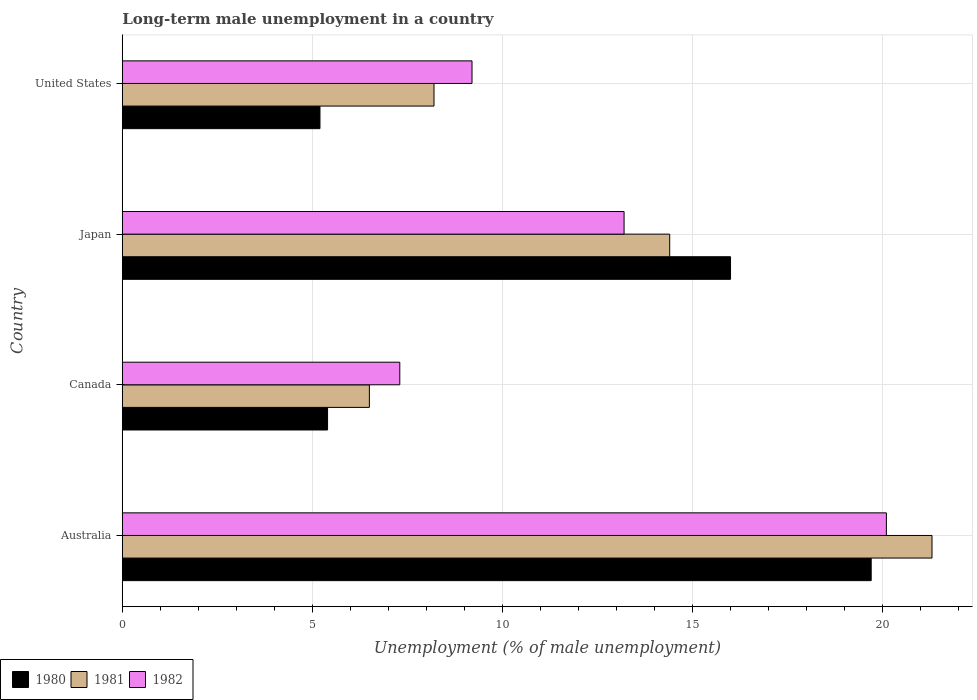Are the number of bars on each tick of the Y-axis equal?
Make the answer very short. Yes. How many bars are there on the 4th tick from the bottom?
Provide a succinct answer. 3. In how many cases, is the number of bars for a given country not equal to the number of legend labels?
Keep it short and to the point. 0. What is the percentage of long-term unemployed male population in 1981 in Japan?
Keep it short and to the point. 14.4. Across all countries, what is the maximum percentage of long-term unemployed male population in 1980?
Make the answer very short. 19.7. In which country was the percentage of long-term unemployed male population in 1981 maximum?
Provide a succinct answer. Australia. What is the total percentage of long-term unemployed male population in 1982 in the graph?
Your answer should be compact. 49.8. What is the difference between the percentage of long-term unemployed male population in 1980 in Japan and that in United States?
Provide a short and direct response. 10.8. What is the difference between the percentage of long-term unemployed male population in 1981 in Canada and the percentage of long-term unemployed male population in 1980 in United States?
Offer a very short reply. 1.3. What is the average percentage of long-term unemployed male population in 1980 per country?
Your answer should be very brief. 11.58. What is the difference between the percentage of long-term unemployed male population in 1982 and percentage of long-term unemployed male population in 1980 in Canada?
Give a very brief answer. 1.9. In how many countries, is the percentage of long-term unemployed male population in 1981 greater than 19 %?
Offer a terse response. 1. What is the ratio of the percentage of long-term unemployed male population in 1982 in Australia to that in Canada?
Provide a succinct answer. 2.75. Is the percentage of long-term unemployed male population in 1982 in Australia less than that in Japan?
Give a very brief answer. No. What is the difference between the highest and the second highest percentage of long-term unemployed male population in 1981?
Your answer should be compact. 6.9. What is the difference between the highest and the lowest percentage of long-term unemployed male population in 1981?
Offer a terse response. 14.8. Is the sum of the percentage of long-term unemployed male population in 1982 in Japan and United States greater than the maximum percentage of long-term unemployed male population in 1981 across all countries?
Offer a terse response. Yes. What does the 3rd bar from the top in Australia represents?
Your response must be concise. 1980. What does the 2nd bar from the bottom in Australia represents?
Provide a succinct answer. 1981. Is it the case that in every country, the sum of the percentage of long-term unemployed male population in 1980 and percentage of long-term unemployed male population in 1982 is greater than the percentage of long-term unemployed male population in 1981?
Offer a very short reply. Yes. Does the graph contain any zero values?
Offer a very short reply. No. Does the graph contain grids?
Offer a terse response. Yes. How many legend labels are there?
Give a very brief answer. 3. How are the legend labels stacked?
Keep it short and to the point. Horizontal. What is the title of the graph?
Keep it short and to the point. Long-term male unemployment in a country. Does "1962" appear as one of the legend labels in the graph?
Your response must be concise. No. What is the label or title of the X-axis?
Offer a terse response. Unemployment (% of male unemployment). What is the label or title of the Y-axis?
Keep it short and to the point. Country. What is the Unemployment (% of male unemployment) in 1980 in Australia?
Ensure brevity in your answer.  19.7. What is the Unemployment (% of male unemployment) of 1981 in Australia?
Your answer should be compact. 21.3. What is the Unemployment (% of male unemployment) of 1982 in Australia?
Provide a short and direct response. 20.1. What is the Unemployment (% of male unemployment) of 1980 in Canada?
Offer a terse response. 5.4. What is the Unemployment (% of male unemployment) of 1981 in Canada?
Provide a short and direct response. 6.5. What is the Unemployment (% of male unemployment) in 1982 in Canada?
Offer a terse response. 7.3. What is the Unemployment (% of male unemployment) in 1981 in Japan?
Ensure brevity in your answer.  14.4. What is the Unemployment (% of male unemployment) in 1982 in Japan?
Make the answer very short. 13.2. What is the Unemployment (% of male unemployment) in 1980 in United States?
Keep it short and to the point. 5.2. What is the Unemployment (% of male unemployment) of 1981 in United States?
Your response must be concise. 8.2. What is the Unemployment (% of male unemployment) in 1982 in United States?
Provide a succinct answer. 9.2. Across all countries, what is the maximum Unemployment (% of male unemployment) of 1980?
Ensure brevity in your answer.  19.7. Across all countries, what is the maximum Unemployment (% of male unemployment) in 1981?
Provide a succinct answer. 21.3. Across all countries, what is the maximum Unemployment (% of male unemployment) in 1982?
Keep it short and to the point. 20.1. Across all countries, what is the minimum Unemployment (% of male unemployment) of 1980?
Ensure brevity in your answer.  5.2. Across all countries, what is the minimum Unemployment (% of male unemployment) of 1981?
Make the answer very short. 6.5. Across all countries, what is the minimum Unemployment (% of male unemployment) in 1982?
Your response must be concise. 7.3. What is the total Unemployment (% of male unemployment) in 1980 in the graph?
Your answer should be compact. 46.3. What is the total Unemployment (% of male unemployment) of 1981 in the graph?
Offer a very short reply. 50.4. What is the total Unemployment (% of male unemployment) of 1982 in the graph?
Your response must be concise. 49.8. What is the difference between the Unemployment (% of male unemployment) of 1980 in Australia and that in Canada?
Provide a succinct answer. 14.3. What is the difference between the Unemployment (% of male unemployment) of 1981 in Australia and that in Canada?
Your answer should be very brief. 14.8. What is the difference between the Unemployment (% of male unemployment) of 1982 in Australia and that in Canada?
Give a very brief answer. 12.8. What is the difference between the Unemployment (% of male unemployment) in 1981 in Australia and that in United States?
Offer a very short reply. 13.1. What is the difference between the Unemployment (% of male unemployment) in 1982 in Australia and that in United States?
Your response must be concise. 10.9. What is the difference between the Unemployment (% of male unemployment) of 1980 in Canada and that in Japan?
Provide a succinct answer. -10.6. What is the difference between the Unemployment (% of male unemployment) in 1982 in Canada and that in United States?
Make the answer very short. -1.9. What is the difference between the Unemployment (% of male unemployment) in 1982 in Japan and that in United States?
Offer a terse response. 4. What is the difference between the Unemployment (% of male unemployment) of 1980 in Australia and the Unemployment (% of male unemployment) of 1981 in Canada?
Make the answer very short. 13.2. What is the difference between the Unemployment (% of male unemployment) of 1981 in Australia and the Unemployment (% of male unemployment) of 1982 in Japan?
Keep it short and to the point. 8.1. What is the difference between the Unemployment (% of male unemployment) of 1980 in Australia and the Unemployment (% of male unemployment) of 1981 in United States?
Offer a very short reply. 11.5. What is the difference between the Unemployment (% of male unemployment) of 1980 in Australia and the Unemployment (% of male unemployment) of 1982 in United States?
Make the answer very short. 10.5. What is the difference between the Unemployment (% of male unemployment) of 1980 in Canada and the Unemployment (% of male unemployment) of 1981 in Japan?
Provide a succinct answer. -9. What is the difference between the Unemployment (% of male unemployment) of 1980 in Canada and the Unemployment (% of male unemployment) of 1981 in United States?
Offer a terse response. -2.8. What is the difference between the Unemployment (% of male unemployment) in 1980 in Canada and the Unemployment (% of male unemployment) in 1982 in United States?
Provide a succinct answer. -3.8. What is the difference between the Unemployment (% of male unemployment) in 1980 in Japan and the Unemployment (% of male unemployment) in 1981 in United States?
Ensure brevity in your answer.  7.8. What is the difference between the Unemployment (% of male unemployment) of 1981 in Japan and the Unemployment (% of male unemployment) of 1982 in United States?
Provide a succinct answer. 5.2. What is the average Unemployment (% of male unemployment) of 1980 per country?
Your response must be concise. 11.57. What is the average Unemployment (% of male unemployment) of 1982 per country?
Keep it short and to the point. 12.45. What is the difference between the Unemployment (% of male unemployment) of 1980 and Unemployment (% of male unemployment) of 1981 in Australia?
Your answer should be very brief. -1.6. What is the difference between the Unemployment (% of male unemployment) in 1980 and Unemployment (% of male unemployment) in 1982 in Australia?
Provide a short and direct response. -0.4. What is the difference between the Unemployment (% of male unemployment) of 1980 and Unemployment (% of male unemployment) of 1981 in Canada?
Ensure brevity in your answer.  -1.1. What is the difference between the Unemployment (% of male unemployment) in 1981 and Unemployment (% of male unemployment) in 1982 in Japan?
Offer a very short reply. 1.2. What is the difference between the Unemployment (% of male unemployment) of 1980 and Unemployment (% of male unemployment) of 1982 in United States?
Your response must be concise. -4. What is the ratio of the Unemployment (% of male unemployment) in 1980 in Australia to that in Canada?
Make the answer very short. 3.65. What is the ratio of the Unemployment (% of male unemployment) of 1981 in Australia to that in Canada?
Provide a short and direct response. 3.28. What is the ratio of the Unemployment (% of male unemployment) in 1982 in Australia to that in Canada?
Provide a short and direct response. 2.75. What is the ratio of the Unemployment (% of male unemployment) in 1980 in Australia to that in Japan?
Make the answer very short. 1.23. What is the ratio of the Unemployment (% of male unemployment) in 1981 in Australia to that in Japan?
Your response must be concise. 1.48. What is the ratio of the Unemployment (% of male unemployment) in 1982 in Australia to that in Japan?
Provide a short and direct response. 1.52. What is the ratio of the Unemployment (% of male unemployment) in 1980 in Australia to that in United States?
Provide a succinct answer. 3.79. What is the ratio of the Unemployment (% of male unemployment) in 1981 in Australia to that in United States?
Your response must be concise. 2.6. What is the ratio of the Unemployment (% of male unemployment) in 1982 in Australia to that in United States?
Provide a succinct answer. 2.18. What is the ratio of the Unemployment (% of male unemployment) of 1980 in Canada to that in Japan?
Give a very brief answer. 0.34. What is the ratio of the Unemployment (% of male unemployment) of 1981 in Canada to that in Japan?
Make the answer very short. 0.45. What is the ratio of the Unemployment (% of male unemployment) of 1982 in Canada to that in Japan?
Give a very brief answer. 0.55. What is the ratio of the Unemployment (% of male unemployment) in 1981 in Canada to that in United States?
Provide a short and direct response. 0.79. What is the ratio of the Unemployment (% of male unemployment) of 1982 in Canada to that in United States?
Offer a very short reply. 0.79. What is the ratio of the Unemployment (% of male unemployment) in 1980 in Japan to that in United States?
Your answer should be compact. 3.08. What is the ratio of the Unemployment (% of male unemployment) in 1981 in Japan to that in United States?
Provide a succinct answer. 1.76. What is the ratio of the Unemployment (% of male unemployment) in 1982 in Japan to that in United States?
Offer a very short reply. 1.43. What is the difference between the highest and the second highest Unemployment (% of male unemployment) in 1980?
Offer a very short reply. 3.7. What is the difference between the highest and the second highest Unemployment (% of male unemployment) of 1981?
Offer a terse response. 6.9. 